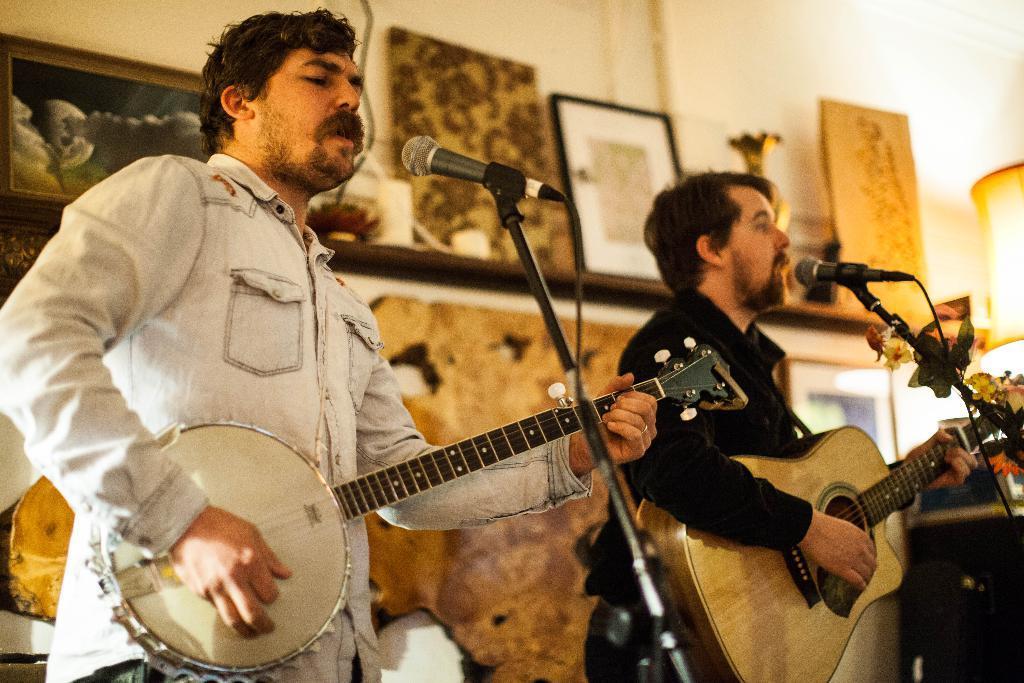In one or two sentences, can you explain what this image depicts? Here we can see two persons are standing and playing the guitar and singing, and in front here is the microphone and stand, and at back here is the wall and photo frames on it. 